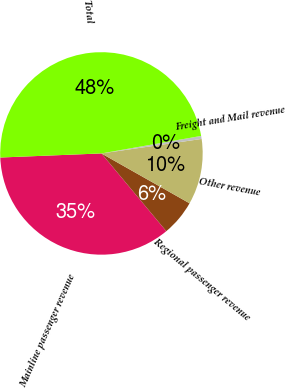Convert chart to OTSL. <chart><loc_0><loc_0><loc_500><loc_500><pie_chart><fcel>Mainline passenger revenue<fcel>Regional passenger revenue<fcel>Other revenue<fcel>Freight and Mail revenue<fcel>Total<nl><fcel>35.42%<fcel>5.74%<fcel>10.48%<fcel>0.48%<fcel>47.87%<nl></chart> 